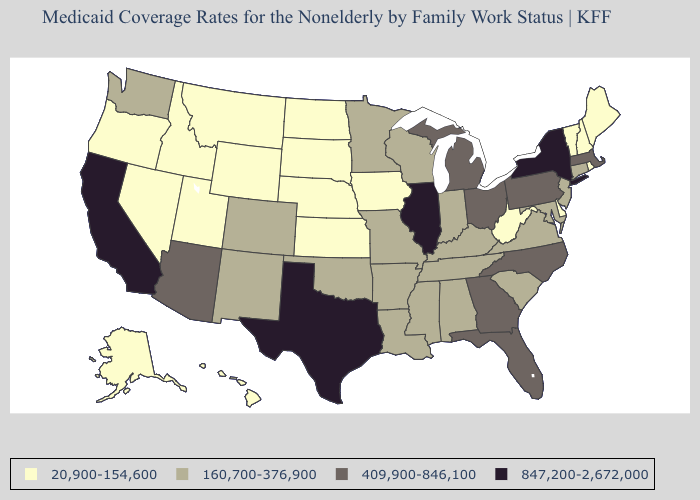Does Maryland have the lowest value in the South?
Be succinct. No. Name the states that have a value in the range 847,200-2,672,000?
Answer briefly. California, Illinois, New York, Texas. What is the value of Alaska?
Write a very short answer. 20,900-154,600. Name the states that have a value in the range 847,200-2,672,000?
Quick response, please. California, Illinois, New York, Texas. What is the value of Utah?
Concise answer only. 20,900-154,600. What is the highest value in the West ?
Give a very brief answer. 847,200-2,672,000. What is the highest value in the MidWest ?
Concise answer only. 847,200-2,672,000. Name the states that have a value in the range 409,900-846,100?
Concise answer only. Arizona, Florida, Georgia, Massachusetts, Michigan, North Carolina, Ohio, Pennsylvania. Among the states that border Georgia , which have the highest value?
Give a very brief answer. Florida, North Carolina. What is the value of South Dakota?
Be succinct. 20,900-154,600. Does New Hampshire have the lowest value in the Northeast?
Quick response, please. Yes. Which states have the lowest value in the USA?
Write a very short answer. Alaska, Delaware, Hawaii, Idaho, Iowa, Kansas, Maine, Montana, Nebraska, Nevada, New Hampshire, North Dakota, Oregon, Rhode Island, South Dakota, Utah, Vermont, West Virginia, Wyoming. Does Illinois have the highest value in the USA?
Give a very brief answer. Yes. Does Illinois have the lowest value in the MidWest?
Give a very brief answer. No. Name the states that have a value in the range 20,900-154,600?
Be succinct. Alaska, Delaware, Hawaii, Idaho, Iowa, Kansas, Maine, Montana, Nebraska, Nevada, New Hampshire, North Dakota, Oregon, Rhode Island, South Dakota, Utah, Vermont, West Virginia, Wyoming. 